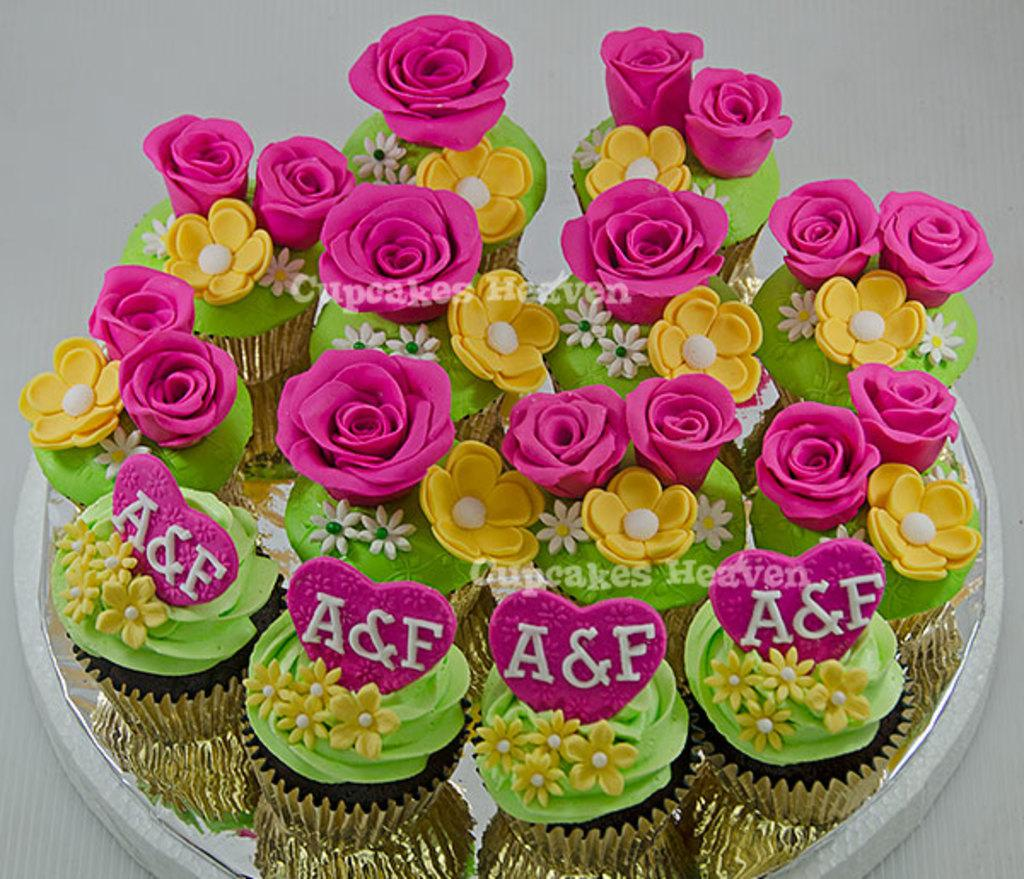What type of dessert is featured in the image? There are cupcakes in the image. What decorations are on the cupcakes? The cupcakes have roses and hearts on them. Is there any text present in the image? Yes, there is text in the image. What type of square locket can be seen hanging from the roses on the cupcakes? There is no square locket present on the cupcakes in the image. 